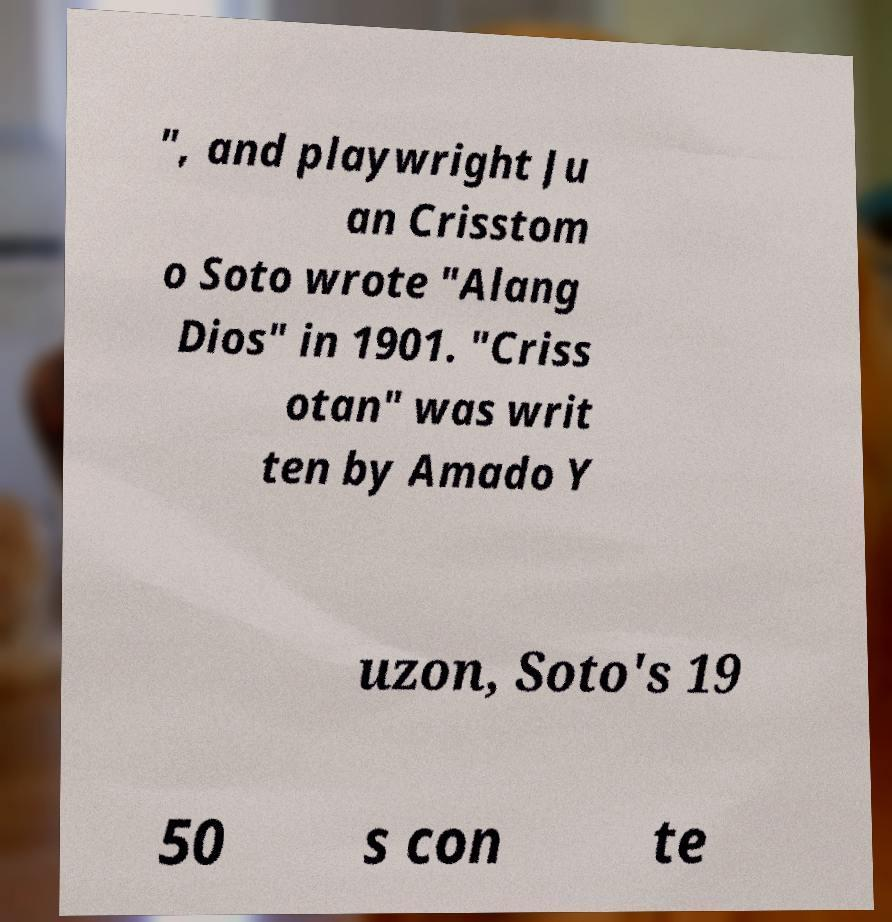Can you read and provide the text displayed in the image?This photo seems to have some interesting text. Can you extract and type it out for me? ", and playwright Ju an Crisstom o Soto wrote "Alang Dios" in 1901. "Criss otan" was writ ten by Amado Y uzon, Soto's 19 50 s con te 